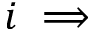Convert formula to latex. <formula><loc_0><loc_0><loc_500><loc_500>i \implies</formula> 